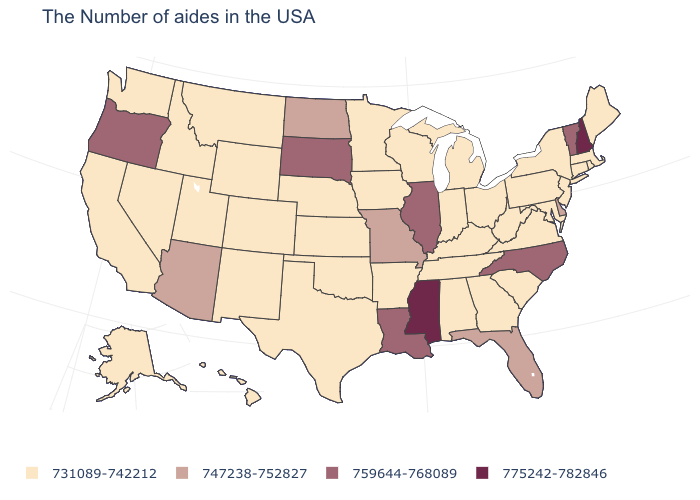Is the legend a continuous bar?
Concise answer only. No. What is the value of New Hampshire?
Give a very brief answer. 775242-782846. Does Colorado have the lowest value in the West?
Short answer required. Yes. What is the value of North Dakota?
Write a very short answer. 747238-752827. Name the states that have a value in the range 759644-768089?
Be succinct. Vermont, North Carolina, Illinois, Louisiana, South Dakota, Oregon. What is the value of Minnesota?
Short answer required. 731089-742212. Which states have the lowest value in the Northeast?
Short answer required. Maine, Massachusetts, Rhode Island, Connecticut, New York, New Jersey, Pennsylvania. Among the states that border Minnesota , which have the lowest value?
Give a very brief answer. Wisconsin, Iowa. What is the value of Montana?
Write a very short answer. 731089-742212. Does Delaware have the lowest value in the USA?
Short answer required. No. What is the highest value in the USA?
Give a very brief answer. 775242-782846. Name the states that have a value in the range 775242-782846?
Quick response, please. New Hampshire, Mississippi. Name the states that have a value in the range 731089-742212?
Short answer required. Maine, Massachusetts, Rhode Island, Connecticut, New York, New Jersey, Maryland, Pennsylvania, Virginia, South Carolina, West Virginia, Ohio, Georgia, Michigan, Kentucky, Indiana, Alabama, Tennessee, Wisconsin, Arkansas, Minnesota, Iowa, Kansas, Nebraska, Oklahoma, Texas, Wyoming, Colorado, New Mexico, Utah, Montana, Idaho, Nevada, California, Washington, Alaska, Hawaii. Does Alaska have a higher value than Oklahoma?
Short answer required. No. Which states have the highest value in the USA?
Give a very brief answer. New Hampshire, Mississippi. 